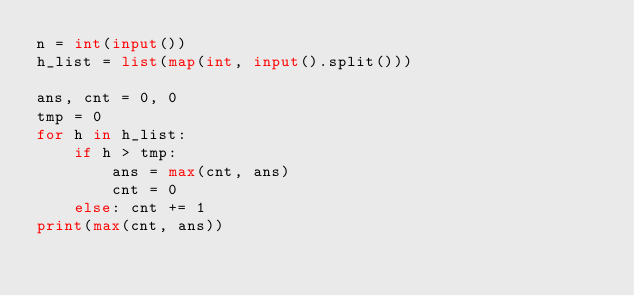Convert code to text. <code><loc_0><loc_0><loc_500><loc_500><_Python_>n = int(input())
h_list = list(map(int, input().split()))

ans, cnt = 0, 0
tmp = 0
for h in h_list:
    if h > tmp:
        ans = max(cnt, ans)
        cnt = 0
    else: cnt += 1
print(max(cnt, ans))
</code> 